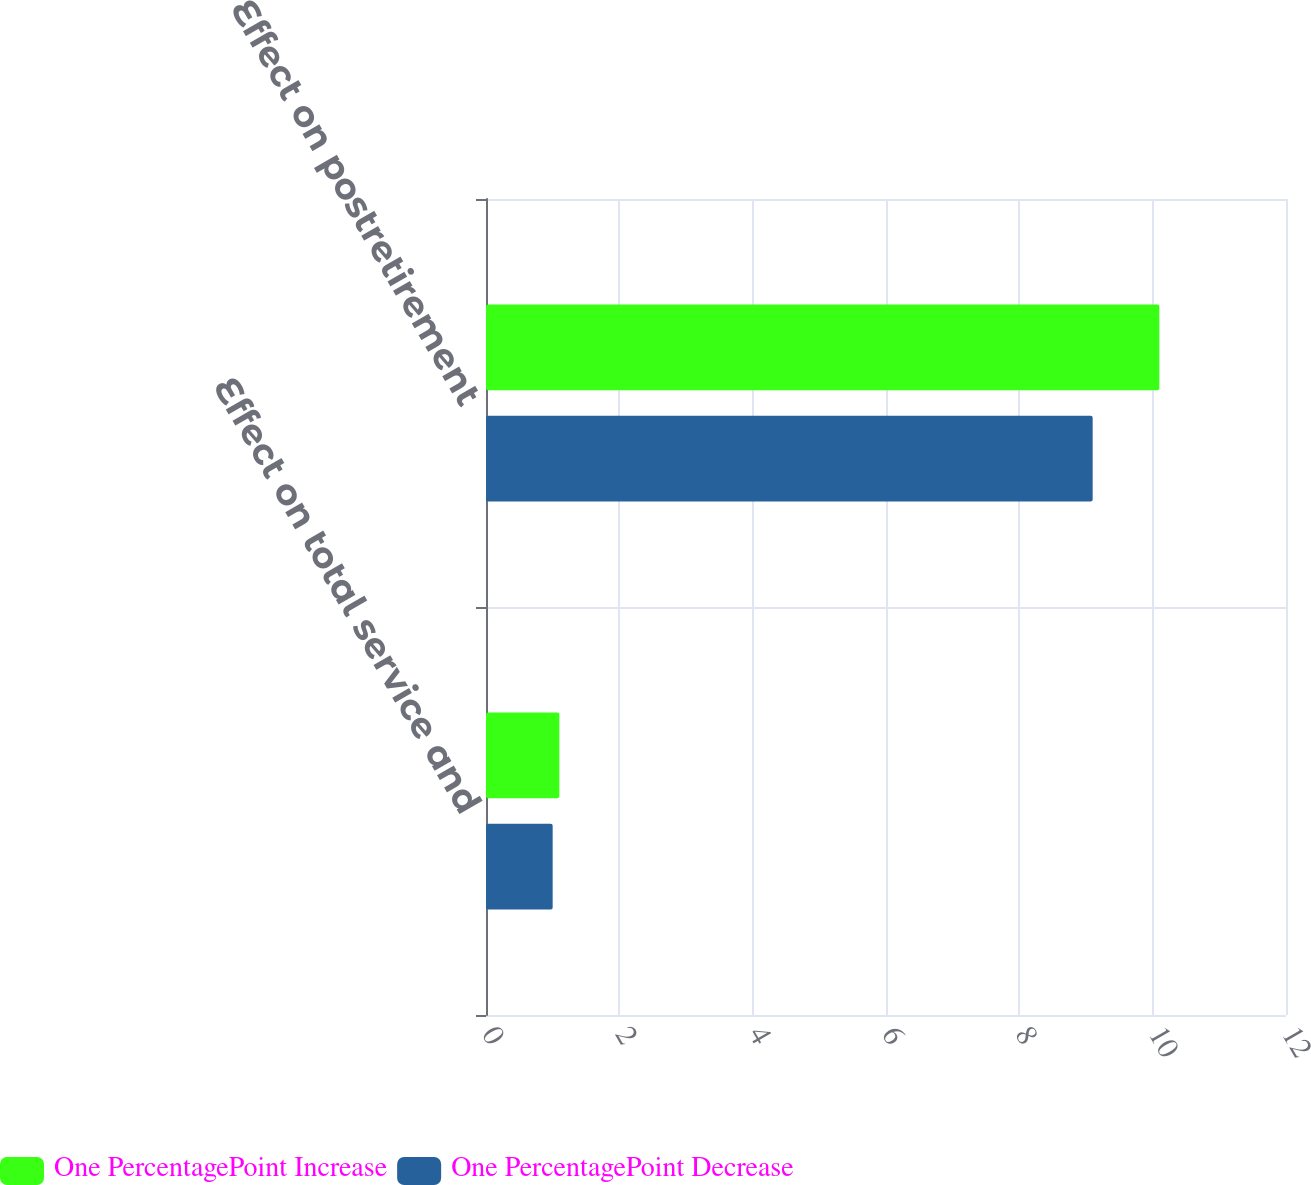Convert chart to OTSL. <chart><loc_0><loc_0><loc_500><loc_500><stacked_bar_chart><ecel><fcel>Effect on total service and<fcel>Effect on postretirement<nl><fcel>One PercentagePoint Increase<fcel>1.1<fcel>10.1<nl><fcel>One PercentagePoint Decrease<fcel>1<fcel>9.1<nl></chart> 